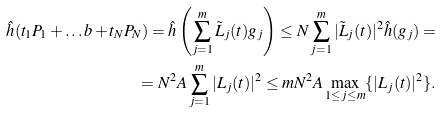<formula> <loc_0><loc_0><loc_500><loc_500>\hat { h } ( t _ { 1 } P _ { 1 } + \dots b + t _ { N } P _ { N } ) = \hat { h } \left ( \sum _ { j = 1 } ^ { m } \tilde { L } _ { j } ( t ) g _ { j } \right ) \leq N \sum _ { j = 1 } ^ { m } | \tilde { L } _ { j } ( t ) | ^ { 2 } \hat { h } ( g _ { j } ) = \\ = N ^ { 2 } A \sum _ { j = 1 } ^ { m } | { L } _ { j } ( t ) | ^ { 2 } \leq m N ^ { 2 } A \max _ { 1 \leq j \leq m } \{ | { L } _ { j } ( t ) | ^ { 2 } \} .</formula> 